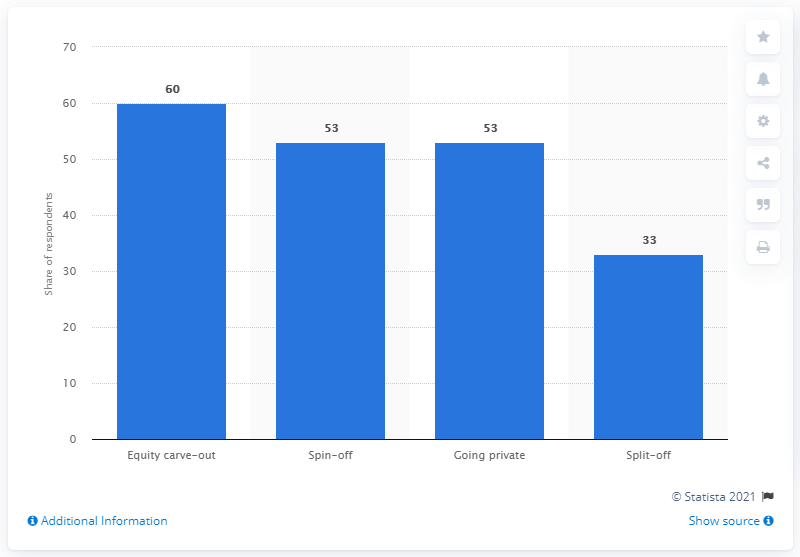Specify some key components in this picture. Sixty percent of respondents agree that European divestitures will take the shape of an equity carve-out. 